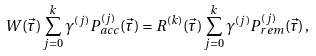<formula> <loc_0><loc_0><loc_500><loc_500>W ( \vec { \tau } ) \sum _ { j = 0 } ^ { k } \gamma ^ { ( j ) } P _ { a c c } ^ { ( j ) } ( \vec { \tau } ) = R ^ { ( k ) } ( \vec { \tau } ) \sum _ { j = 0 } ^ { k } \gamma ^ { ( j ) } P _ { r e m } ^ { ( j ) } ( \vec { \tau } ) \, ,</formula> 